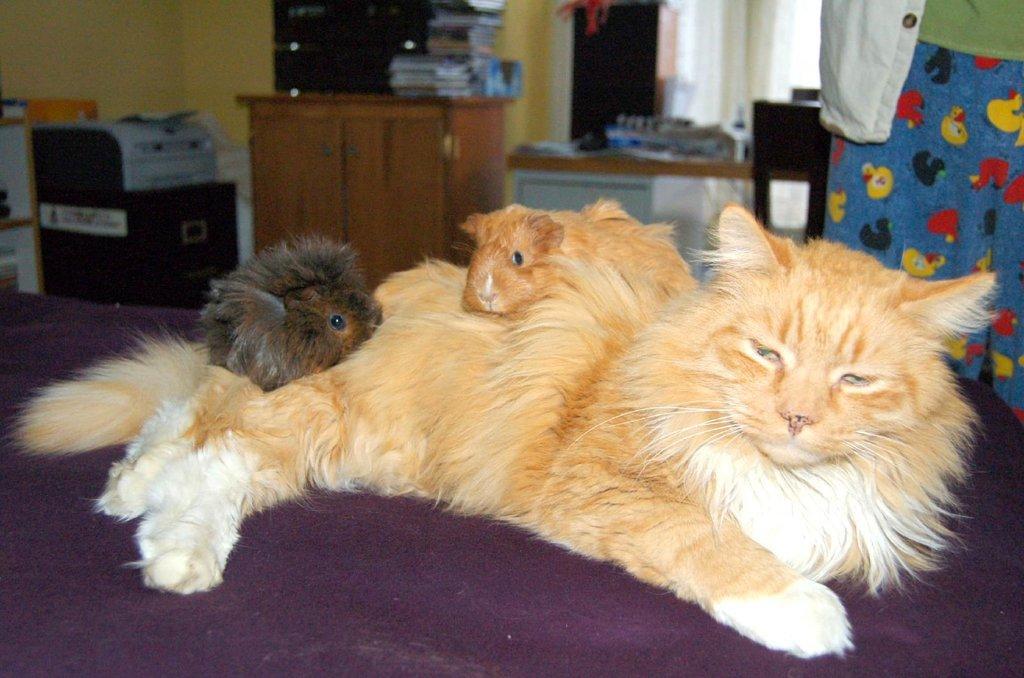Please provide a concise description of this image. In this image we can see animals lying on the cot. In the background there are television set, books on the cabinet, printer, persons standing, curtains and walls. 